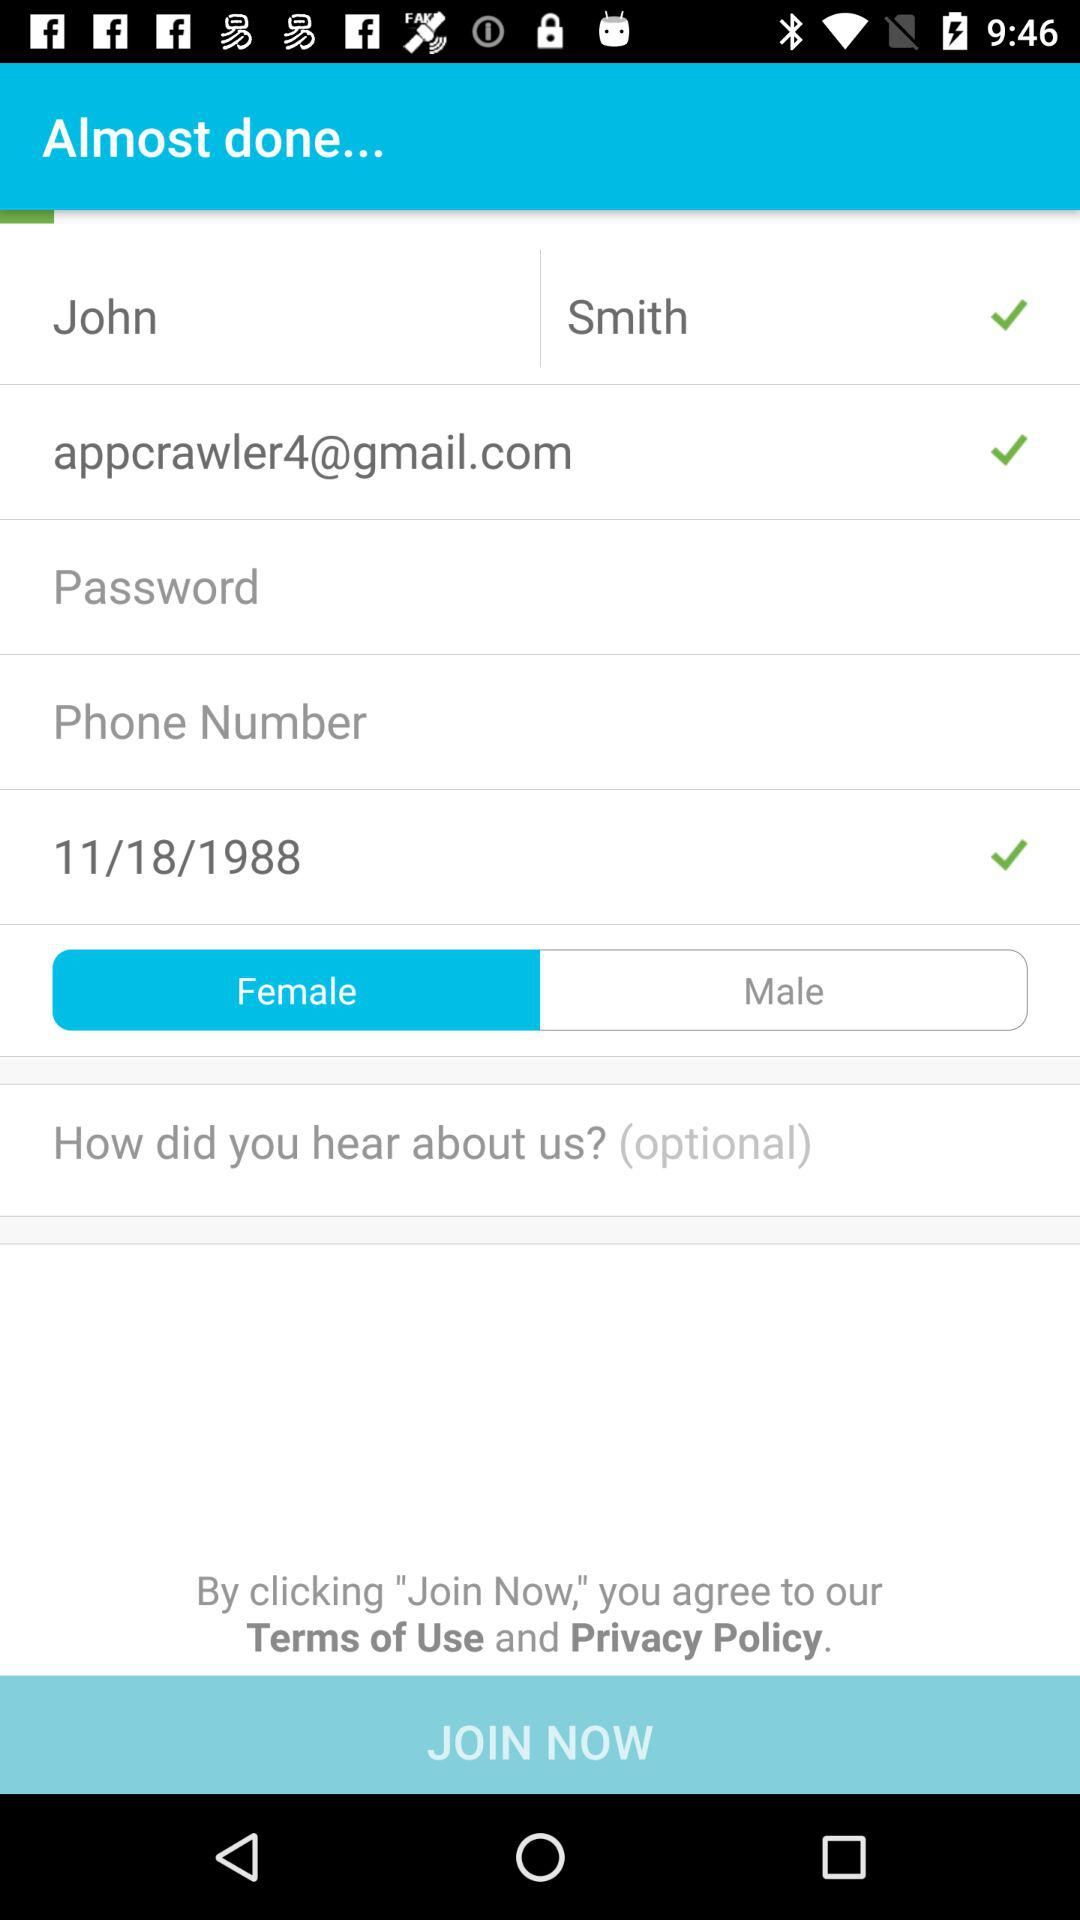What is the email address? The email address is appcrawler4@gmail.com. 